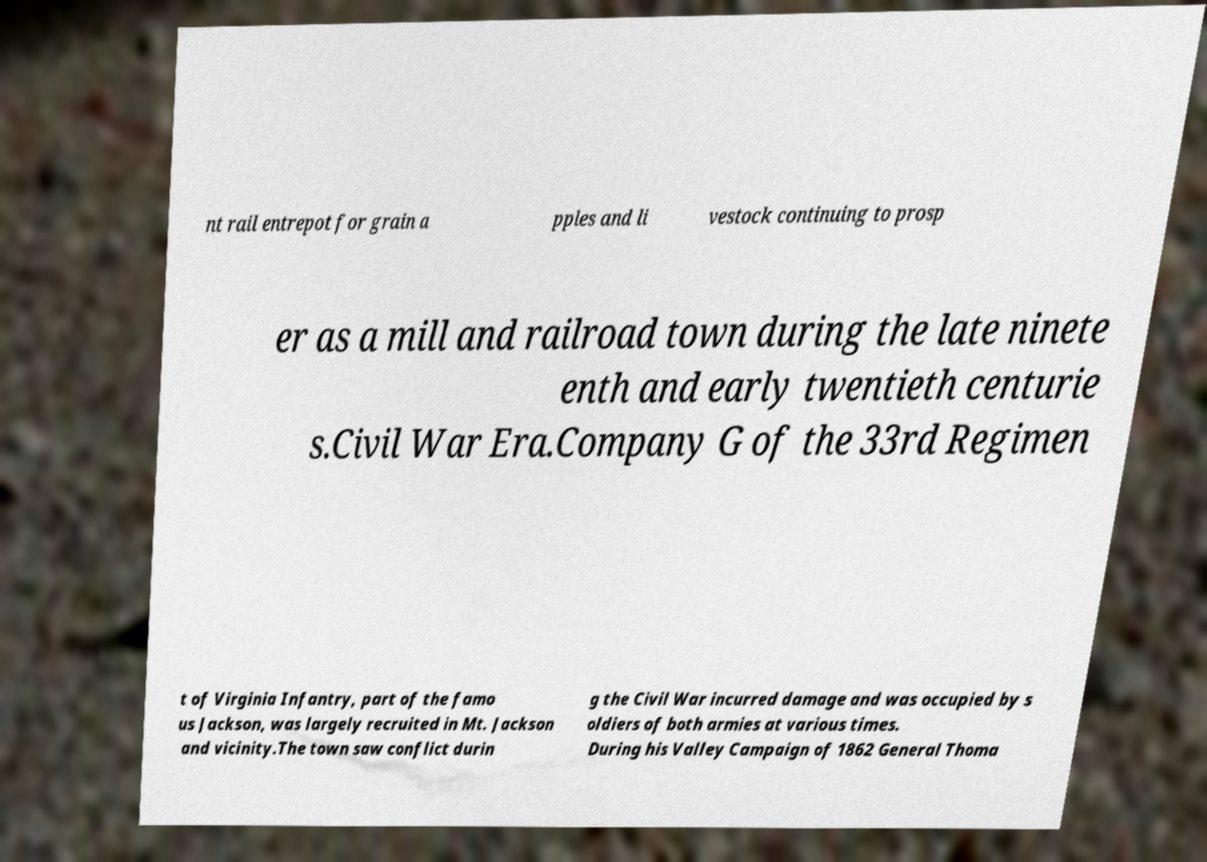I need the written content from this picture converted into text. Can you do that? nt rail entrepot for grain a pples and li vestock continuing to prosp er as a mill and railroad town during the late ninete enth and early twentieth centurie s.Civil War Era.Company G of the 33rd Regimen t of Virginia Infantry, part of the famo us Jackson, was largely recruited in Mt. Jackson and vicinity.The town saw conflict durin g the Civil War incurred damage and was occupied by s oldiers of both armies at various times. During his Valley Campaign of 1862 General Thoma 